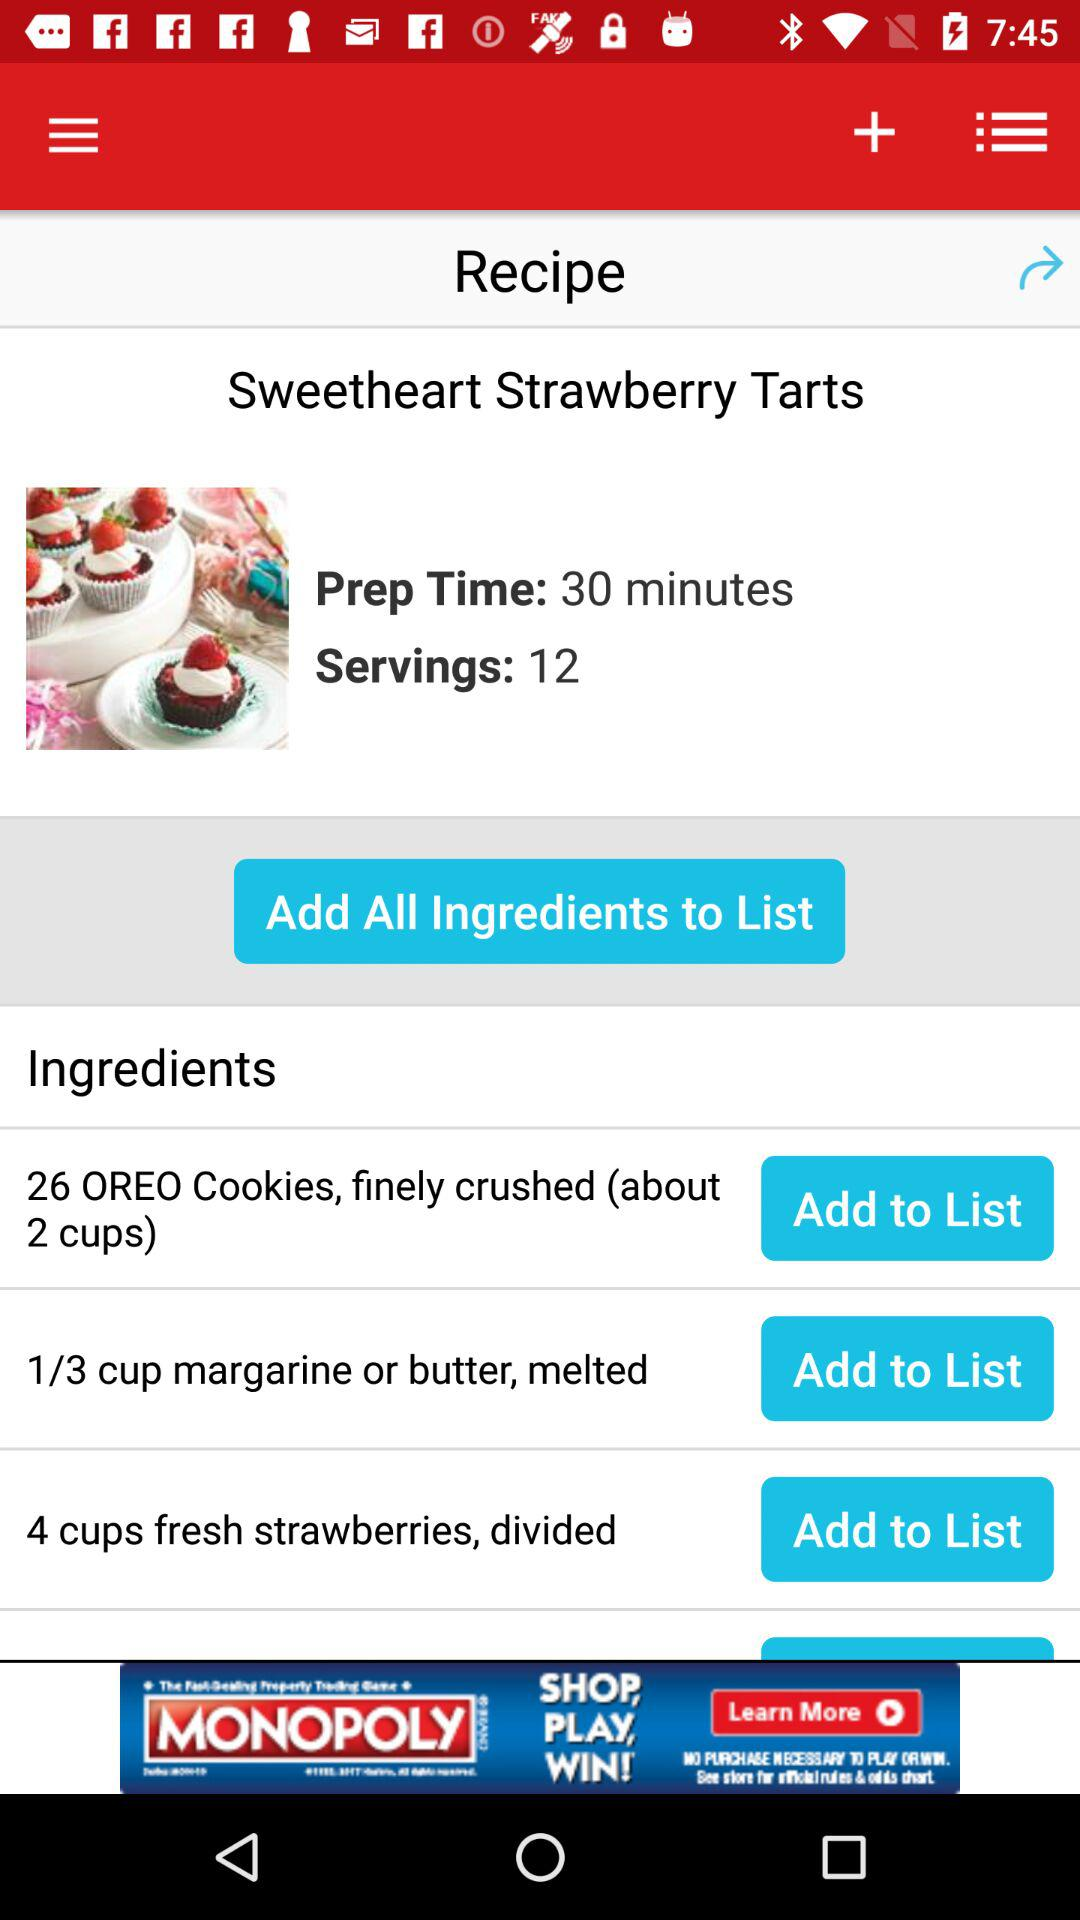Which are the different ingredients? The different ingredients are "26 OREO Cookies, finely crushed (about 2 cups)", "1/3 cup margarine or butter, melted" and "4 cups fresh strawberries, divided". 